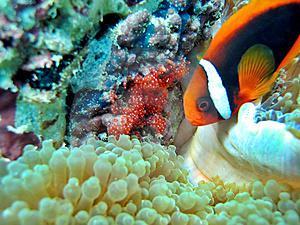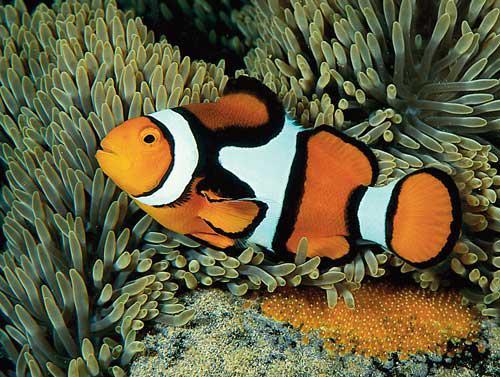The first image is the image on the left, the second image is the image on the right. Analyze the images presented: Is the assertion "One image shows a single prominent clownfish with head and body facing left, in front of neutral-colored anemone tendrils." valid? Answer yes or no. Yes. The first image is the image on the left, the second image is the image on the right. Assess this claim about the two images: "At least 2 clown fish are swimming near a large sea urchin.". Correct or not? Answer yes or no. No. 